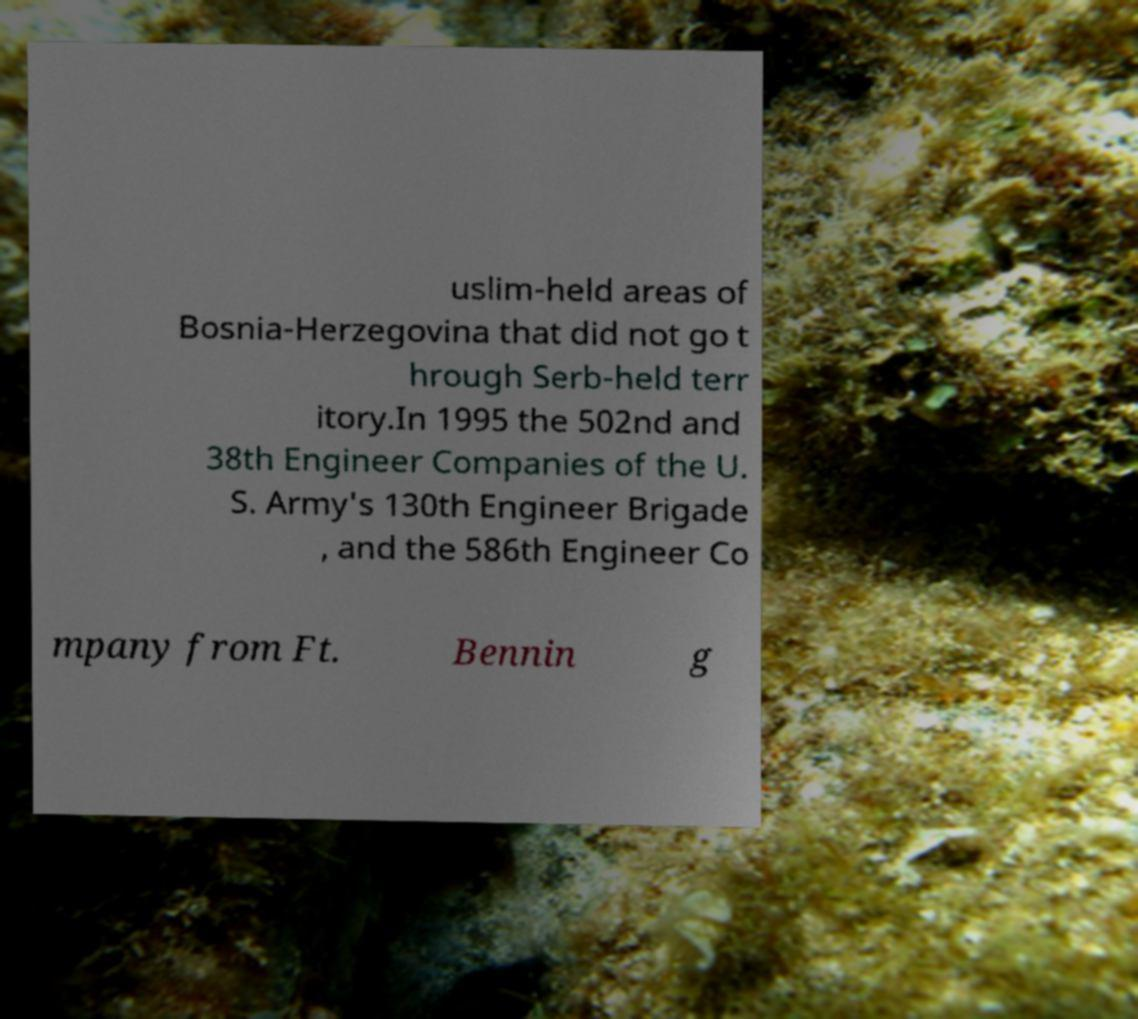Can you accurately transcribe the text from the provided image for me? uslim-held areas of Bosnia-Herzegovina that did not go t hrough Serb-held terr itory.In 1995 the 502nd and 38th Engineer Companies of the U. S. Army's 130th Engineer Brigade , and the 586th Engineer Co mpany from Ft. Bennin g 